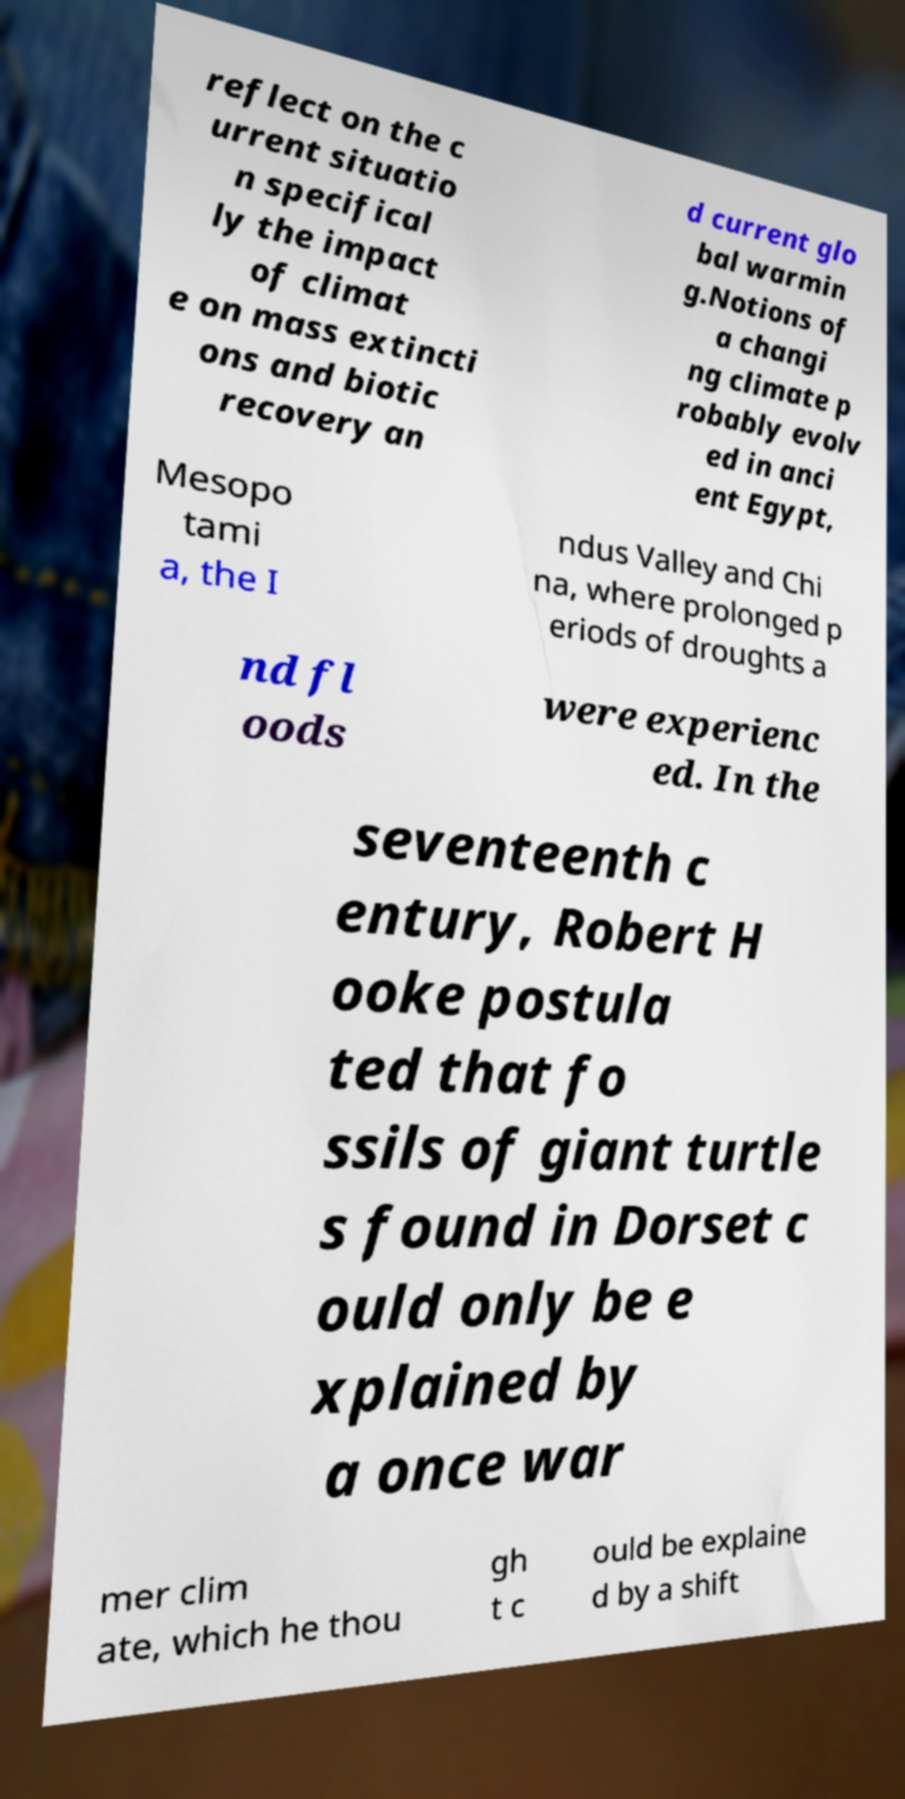Could you assist in decoding the text presented in this image and type it out clearly? reflect on the c urrent situatio n specifical ly the impact of climat e on mass extincti ons and biotic recovery an d current glo bal warmin g.Notions of a changi ng climate p robably evolv ed in anci ent Egypt, Mesopo tami a, the I ndus Valley and Chi na, where prolonged p eriods of droughts a nd fl oods were experienc ed. In the seventeenth c entury, Robert H ooke postula ted that fo ssils of giant turtle s found in Dorset c ould only be e xplained by a once war mer clim ate, which he thou gh t c ould be explaine d by a shift 